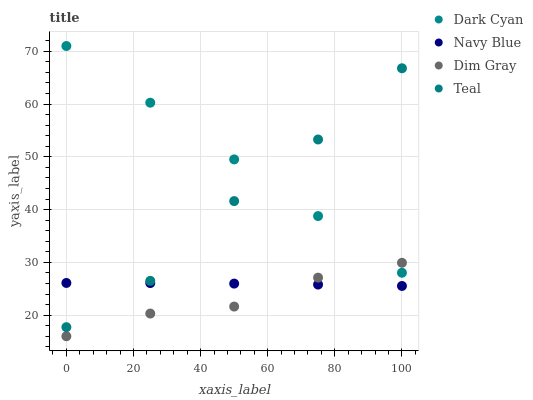Does Dim Gray have the minimum area under the curve?
Answer yes or no. Yes. Does Dark Cyan have the maximum area under the curve?
Answer yes or no. Yes. Does Navy Blue have the minimum area under the curve?
Answer yes or no. No. Does Navy Blue have the maximum area under the curve?
Answer yes or no. No. Is Dark Cyan the smoothest?
Answer yes or no. Yes. Is Teal the roughest?
Answer yes or no. Yes. Is Navy Blue the smoothest?
Answer yes or no. No. Is Navy Blue the roughest?
Answer yes or no. No. Does Dim Gray have the lowest value?
Answer yes or no. Yes. Does Navy Blue have the lowest value?
Answer yes or no. No. Does Dark Cyan have the highest value?
Answer yes or no. Yes. Does Dim Gray have the highest value?
Answer yes or no. No. Is Navy Blue less than Dark Cyan?
Answer yes or no. Yes. Is Dark Cyan greater than Navy Blue?
Answer yes or no. Yes. Does Teal intersect Navy Blue?
Answer yes or no. Yes. Is Teal less than Navy Blue?
Answer yes or no. No. Is Teal greater than Navy Blue?
Answer yes or no. No. Does Navy Blue intersect Dark Cyan?
Answer yes or no. No. 